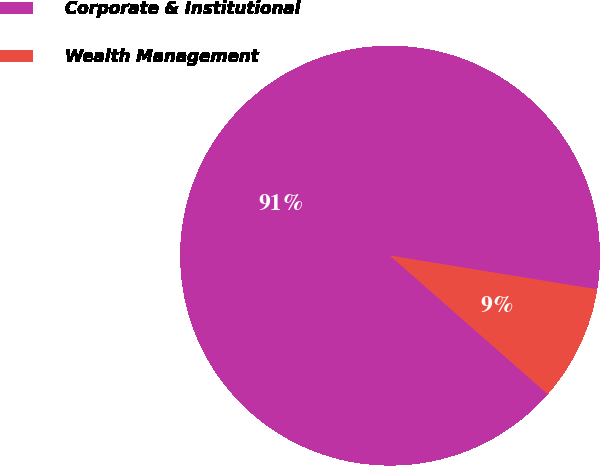Convert chart. <chart><loc_0><loc_0><loc_500><loc_500><pie_chart><fcel>Corporate & Institutional<fcel>Wealth Management<nl><fcel>91.1%<fcel>8.9%<nl></chart> 